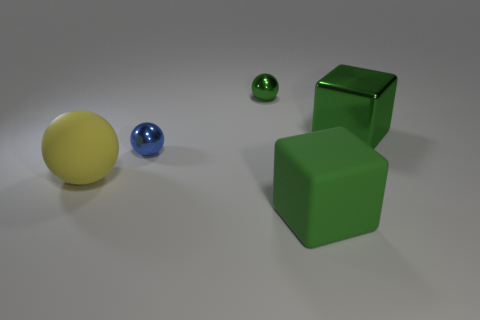What material is the thing in front of the large rubber object that is behind the rubber thing in front of the big yellow object made of?
Provide a short and direct response. Rubber. What is the shape of the small thing in front of the green sphere?
Your answer should be compact. Sphere. What is the size of the block that is the same material as the big yellow ball?
Offer a terse response. Large. How many other things are the same shape as the tiny green thing?
Make the answer very short. 2. Is the color of the large block in front of the yellow matte ball the same as the big sphere?
Offer a terse response. No. There is a green metal thing in front of the ball that is behind the small blue object; what number of tiny things are left of it?
Your answer should be compact. 2. What number of objects are both in front of the large metallic thing and left of the big rubber block?
Your answer should be compact. 2. What shape is the small metal thing that is the same color as the large shiny cube?
Provide a succinct answer. Sphere. Do the big yellow ball and the green sphere have the same material?
Your answer should be compact. No. What shape is the big green object behind the large yellow matte object that is behind the big green block in front of the big yellow matte sphere?
Keep it short and to the point. Cube. 